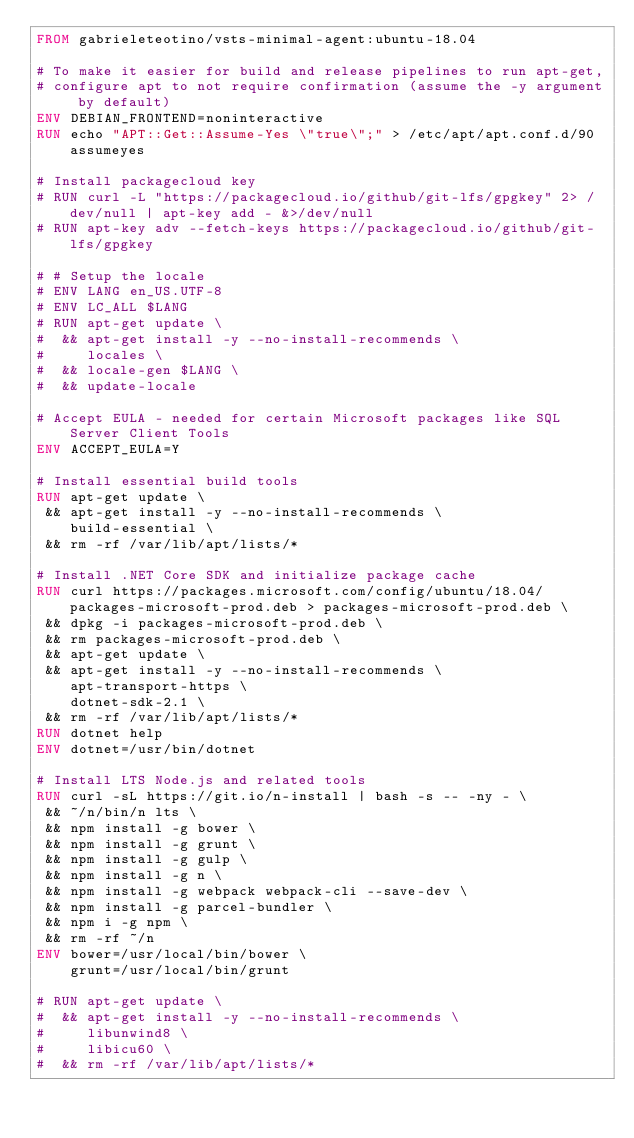Convert code to text. <code><loc_0><loc_0><loc_500><loc_500><_Dockerfile_>FROM gabrieleteotino/vsts-minimal-agent:ubuntu-18.04

# To make it easier for build and release pipelines to run apt-get,
# configure apt to not require confirmation (assume the -y argument by default)
ENV DEBIAN_FRONTEND=noninteractive
RUN echo "APT::Get::Assume-Yes \"true\";" > /etc/apt/apt.conf.d/90assumeyes

# Install packagecloud key
# RUN curl -L "https://packagecloud.io/github/git-lfs/gpgkey" 2> /dev/null | apt-key add - &>/dev/null
# RUN apt-key adv --fetch-keys https://packagecloud.io/github/git-lfs/gpgkey

# # Setup the locale
# ENV LANG en_US.UTF-8
# ENV LC_ALL $LANG
# RUN apt-get update \
#  && apt-get install -y --no-install-recommends \ 
#     locales \
#  && locale-gen $LANG \
#  && update-locale

# Accept EULA - needed for certain Microsoft packages like SQL Server Client Tools
ENV ACCEPT_EULA=Y

# Install essential build tools
RUN apt-get update \
 && apt-get install -y --no-install-recommends \
    build-essential \
 && rm -rf /var/lib/apt/lists/*

# Install .NET Core SDK and initialize package cache
RUN curl https://packages.microsoft.com/config/ubuntu/18.04/packages-microsoft-prod.deb > packages-microsoft-prod.deb \
 && dpkg -i packages-microsoft-prod.deb \
 && rm packages-microsoft-prod.deb \
 && apt-get update \
 && apt-get install -y --no-install-recommends \
    apt-transport-https \
    dotnet-sdk-2.1 \
 && rm -rf /var/lib/apt/lists/*
RUN dotnet help
ENV dotnet=/usr/bin/dotnet

# Install LTS Node.js and related tools
RUN curl -sL https://git.io/n-install | bash -s -- -ny - \
 && ~/n/bin/n lts \
 && npm install -g bower \
 && npm install -g grunt \
 && npm install -g gulp \
 && npm install -g n \
 && npm install -g webpack webpack-cli --save-dev \
 && npm install -g parcel-bundler \
 && npm i -g npm \
 && rm -rf ~/n
ENV bower=/usr/local/bin/bower \
    grunt=/usr/local/bin/grunt

# RUN apt-get update \
#  && apt-get install -y --no-install-recommends \
#     libunwind8 \
#     libicu60 \
#  && rm -rf /var/lib/apt/lists/*
</code> 